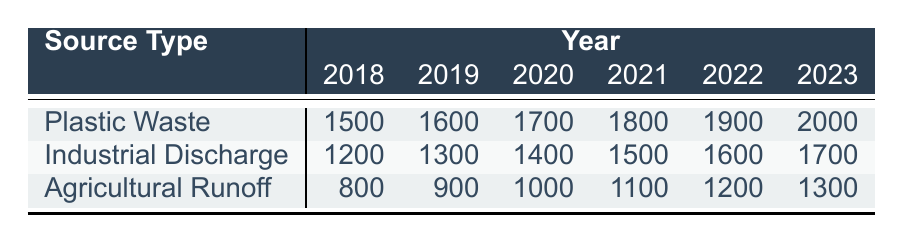What was the pollution level from Plastic Waste in 2019? According to the table, the pollution level for Plastic Waste in 2019 is listed in the corresponding row and column. It can be found directly under the year 2019 for the Plastic Waste source type, which shows a value of 1600.
Answer: 1600 Which source type showed the highest pollution level in 2021? To find the source type with the highest pollution level in 2021, we compare all the pollution levels for that year. The values are: Plastic Waste (1800), Industrial Discharge (1500), and Agricultural Runoff (1100). The highest among these is 1800 from Plastic Waste.
Answer: Plastic Waste What is the total pollution level from Agricultural Runoff across all years? We need to sum the pollution levels for Agricultural Runoff from each year: 800 (2018) + 900 (2019) + 1000 (2020) + 1100 (2021) + 1200 (2022) + 1300 (2023) = 5400. This gives a total pollution level for Agricultural Runoff across all years.
Answer: 5400 Was the pollution level from Industrial Discharge higher than that from Plastic Waste in 2020? In 2020, the pollution level for Industrial Discharge is 1400 and for Plastic Waste it is 1700. Since 1700 is greater than 1400, Industrial Discharge was not higher than Plastic Waste in that year.
Answer: No What is the average pollution level from Plastic Waste over the years 2018 to 2023? To calculate the average, we first sum the pollution levels for Plastic Waste: 1500 (2018) + 1600 (2019) + 1700 (2020) + 1800 (2021) + 1900 (2022) + 2000 (2023) = 11500. There are 6 years, so we divide by 6: 11500 / 6 = approximately 1916.67.
Answer: 1916.67 